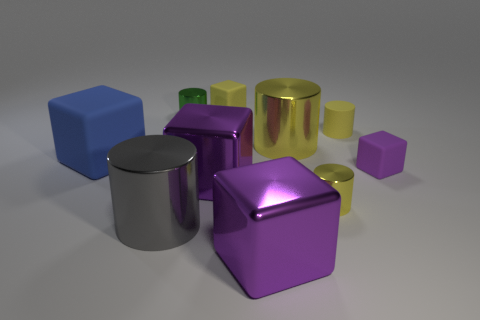Are there the same number of yellow metal cylinders left of the big blue object and blue rubber objects that are on the right side of the tiny yellow cube?
Your response must be concise. Yes. What number of brown things are large shiny cubes or big matte balls?
Make the answer very short. 0. Does the tiny matte cylinder have the same color as the matte block that is behind the big blue rubber thing?
Your response must be concise. Yes. How many other objects are the same color as the small matte cylinder?
Your answer should be very brief. 3. Is the number of large metal cylinders less than the number of small green cylinders?
Your answer should be compact. No. There is a purple object that is in front of the metallic block behind the gray shiny cylinder; how many yellow metal cylinders are left of it?
Offer a very short reply. 0. What is the size of the yellow metallic cylinder behind the large matte thing?
Offer a terse response. Large. Is the shape of the metallic thing behind the big yellow cylinder the same as  the big blue rubber thing?
Offer a very short reply. No. What is the material of the yellow object that is the same shape as the purple matte thing?
Keep it short and to the point. Rubber. Are any big yellow metallic cylinders visible?
Keep it short and to the point. Yes. 